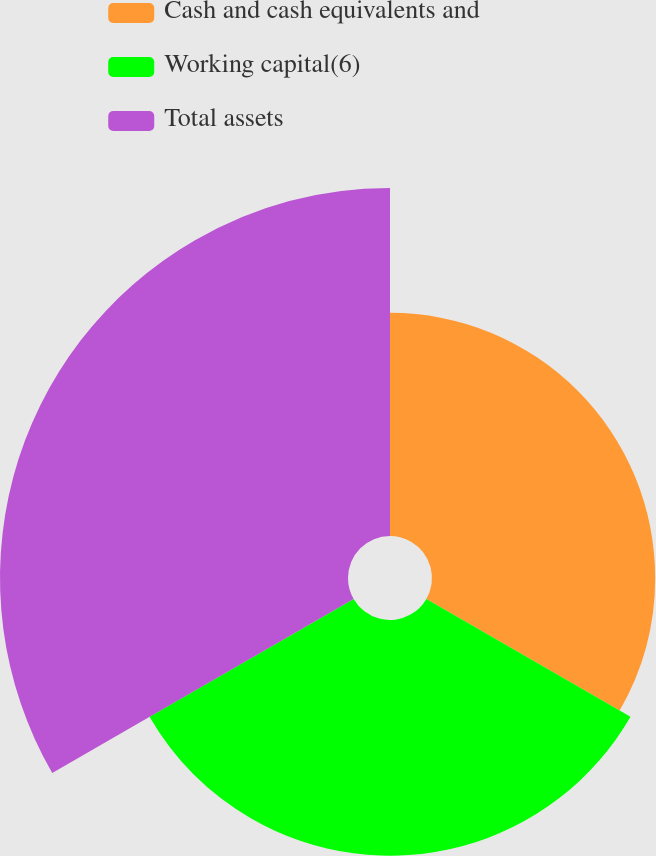Convert chart to OTSL. <chart><loc_0><loc_0><loc_500><loc_500><pie_chart><fcel>Cash and cash equivalents and<fcel>Working capital(6)<fcel>Total assets<nl><fcel>27.66%<fcel>29.21%<fcel>43.13%<nl></chart> 